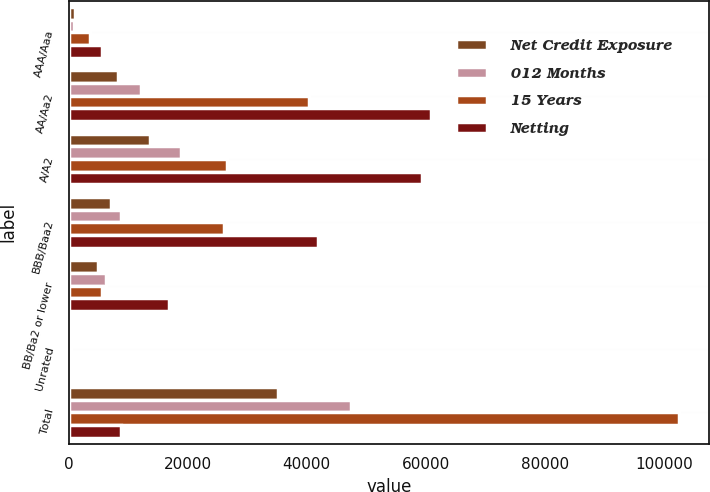Convert chart to OTSL. <chart><loc_0><loc_0><loc_500><loc_500><stacked_bar_chart><ecel><fcel>AAA/Aaa<fcel>AA/Aa2<fcel>A/A2<fcel>BBB/Baa2<fcel>BB/Ba2 or lower<fcel>Unrated<fcel>Total<nl><fcel>Net Credit Exposure<fcel>1119<fcel>8260<fcel>13719<fcel>7049<fcel>4959<fcel>79<fcel>35185<nl><fcel>012 Months<fcel>898<fcel>12182<fcel>18949<fcel>8758<fcel>6226<fcel>363<fcel>47376<nl><fcel>15 Years<fcel>3500<fcel>40443<fcel>26649<fcel>26087<fcel>5660<fcel>160<fcel>102499<nl><fcel>Netting<fcel>5517<fcel>60885<fcel>59317<fcel>41894<fcel>16845<fcel>602<fcel>8758<nl></chart> 